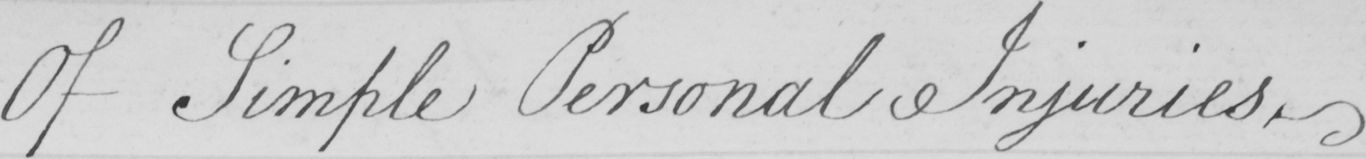Can you read and transcribe this handwriting? Of Simple Personal Injuries . 